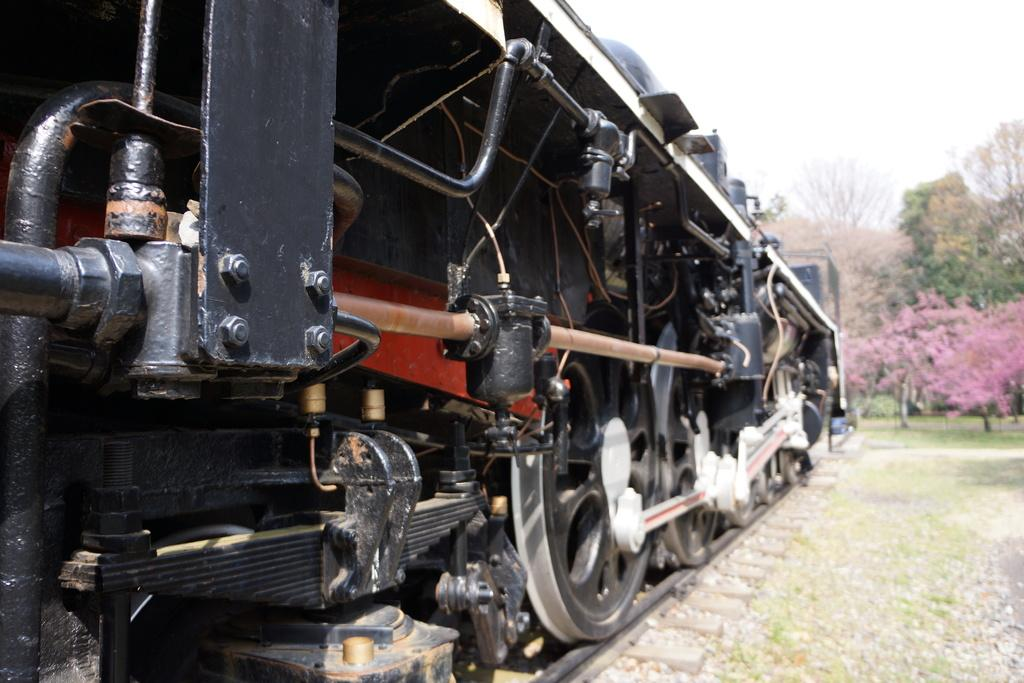What is the main subject on the left side of the image? There is a train engine on the left side of the image. What type of vegetation is on the right side of the image? There are trees on the right side of the image. What is visible at the top of the image? The sky is visible at the top of the image. How many eyes can be seen on the train engine in the image? There are no eyes present on the train engine in the image. What type of salt is being used to season the trees in the image? There is no salt present in the image, and the trees are not being seasoned. 